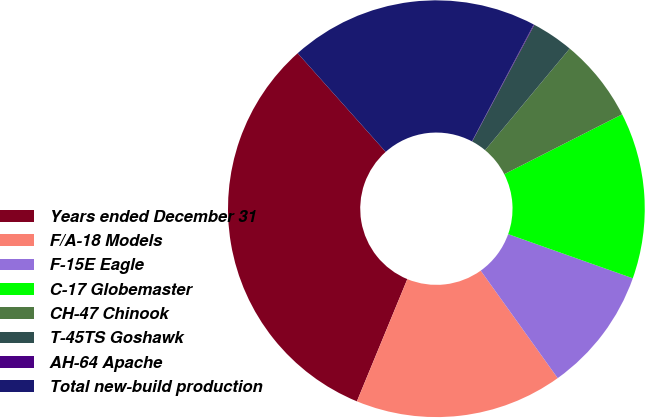Convert chart to OTSL. <chart><loc_0><loc_0><loc_500><loc_500><pie_chart><fcel>Years ended December 31<fcel>F/A-18 Models<fcel>F-15E Eagle<fcel>C-17 Globemaster<fcel>CH-47 Chinook<fcel>T-45TS Goshawk<fcel>AH-64 Apache<fcel>Total new-build production<nl><fcel>32.18%<fcel>16.12%<fcel>9.69%<fcel>12.9%<fcel>6.47%<fcel>3.26%<fcel>0.05%<fcel>19.33%<nl></chart> 